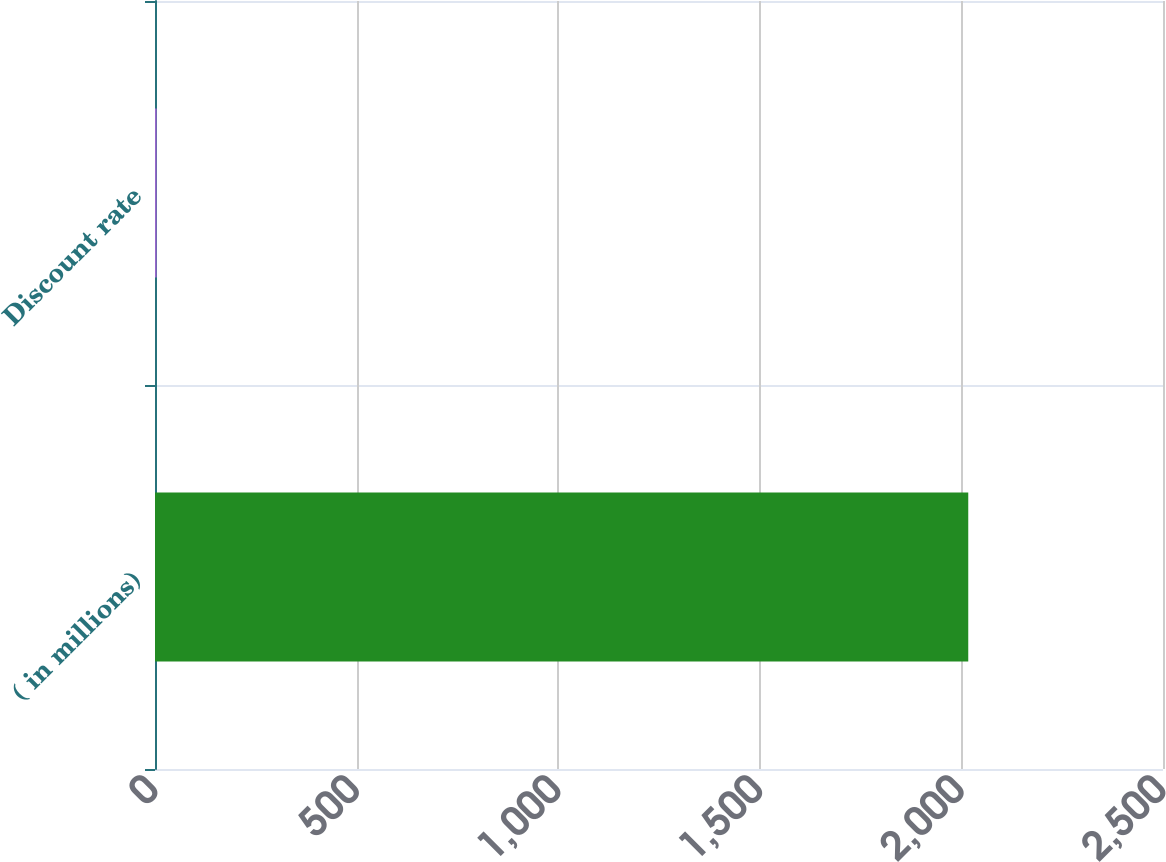Convert chart. <chart><loc_0><loc_0><loc_500><loc_500><bar_chart><fcel>( in millions)<fcel>Discount rate<nl><fcel>2017<fcel>4.15<nl></chart> 